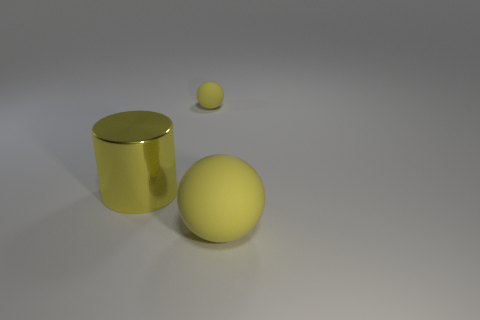What is the size of the other object that is the same material as the small thing?
Provide a short and direct response. Large. Are there any small metal balls of the same color as the big rubber thing?
Keep it short and to the point. No. Is the tiny ball made of the same material as the big sphere?
Ensure brevity in your answer.  Yes. What number of large yellow matte objects have the same shape as the small yellow thing?
Make the answer very short. 1. The thing that is made of the same material as the tiny yellow sphere is what shape?
Your answer should be compact. Sphere. There is a object in front of the large object that is to the left of the big yellow matte ball; what is its color?
Your answer should be compact. Yellow. Do the tiny object and the large rubber thing have the same color?
Provide a succinct answer. Yes. What material is the yellow sphere behind the big yellow matte object right of the yellow cylinder made of?
Ensure brevity in your answer.  Rubber. Is there a small yellow ball behind the large thing behind the large yellow object in front of the metallic cylinder?
Ensure brevity in your answer.  Yes. How many other objects are the same color as the small ball?
Give a very brief answer. 2. 